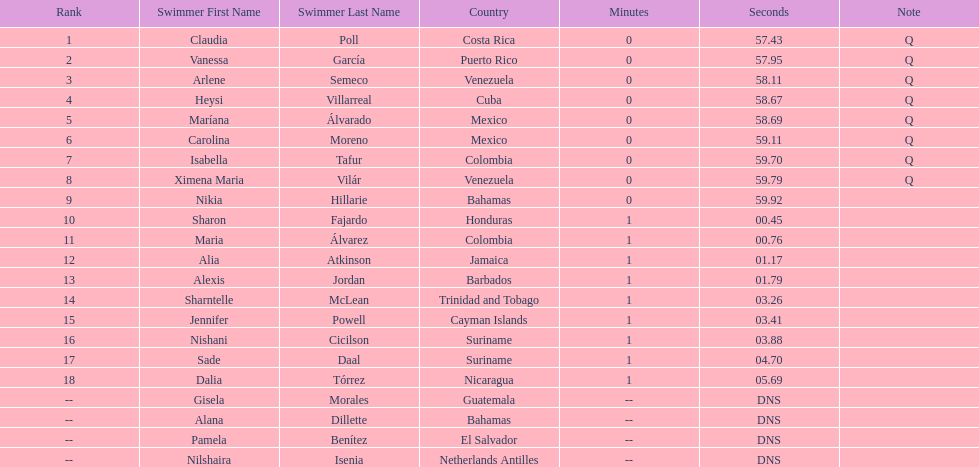How many mexican swimmers ranked in the top 10? 2. 